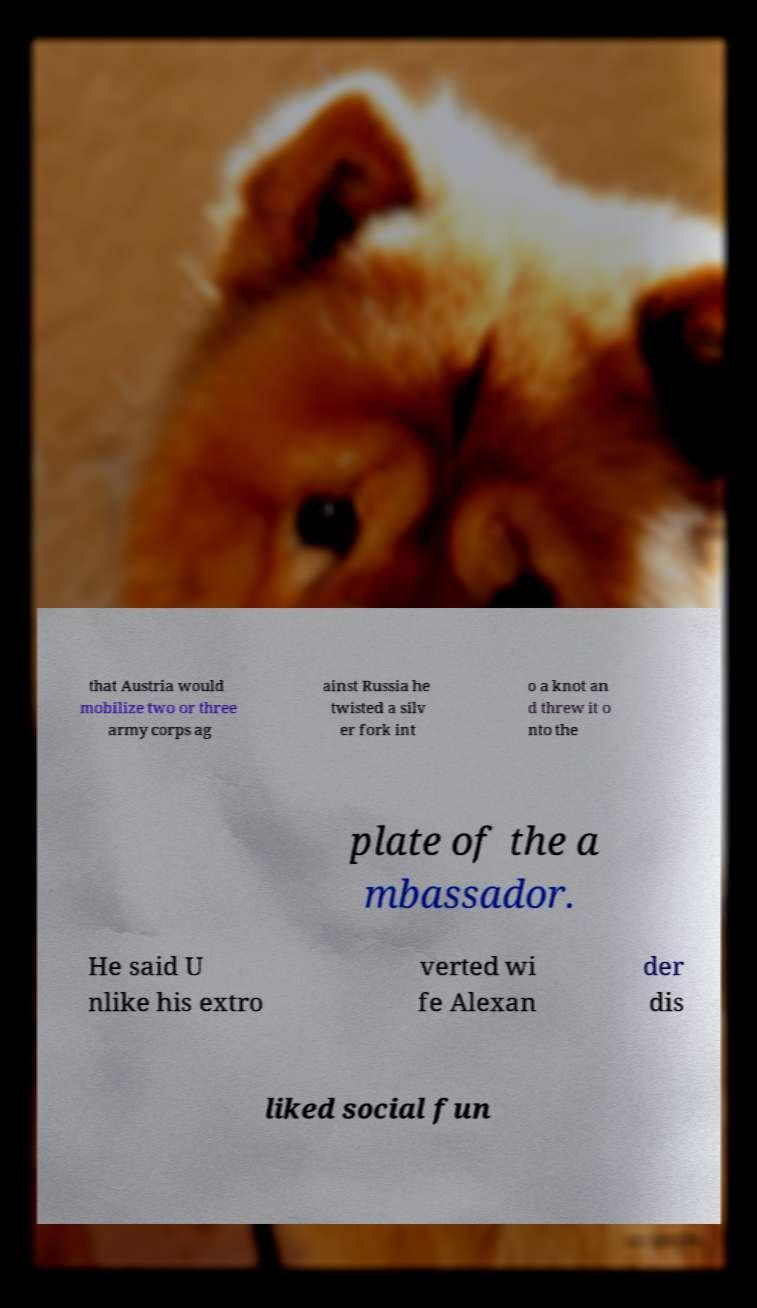Can you accurately transcribe the text from the provided image for me? that Austria would mobilize two or three army corps ag ainst Russia he twisted a silv er fork int o a knot an d threw it o nto the plate of the a mbassador. He said U nlike his extro verted wi fe Alexan der dis liked social fun 